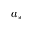<formula> <loc_0><loc_0><loc_500><loc_500>a _ { * }</formula> 